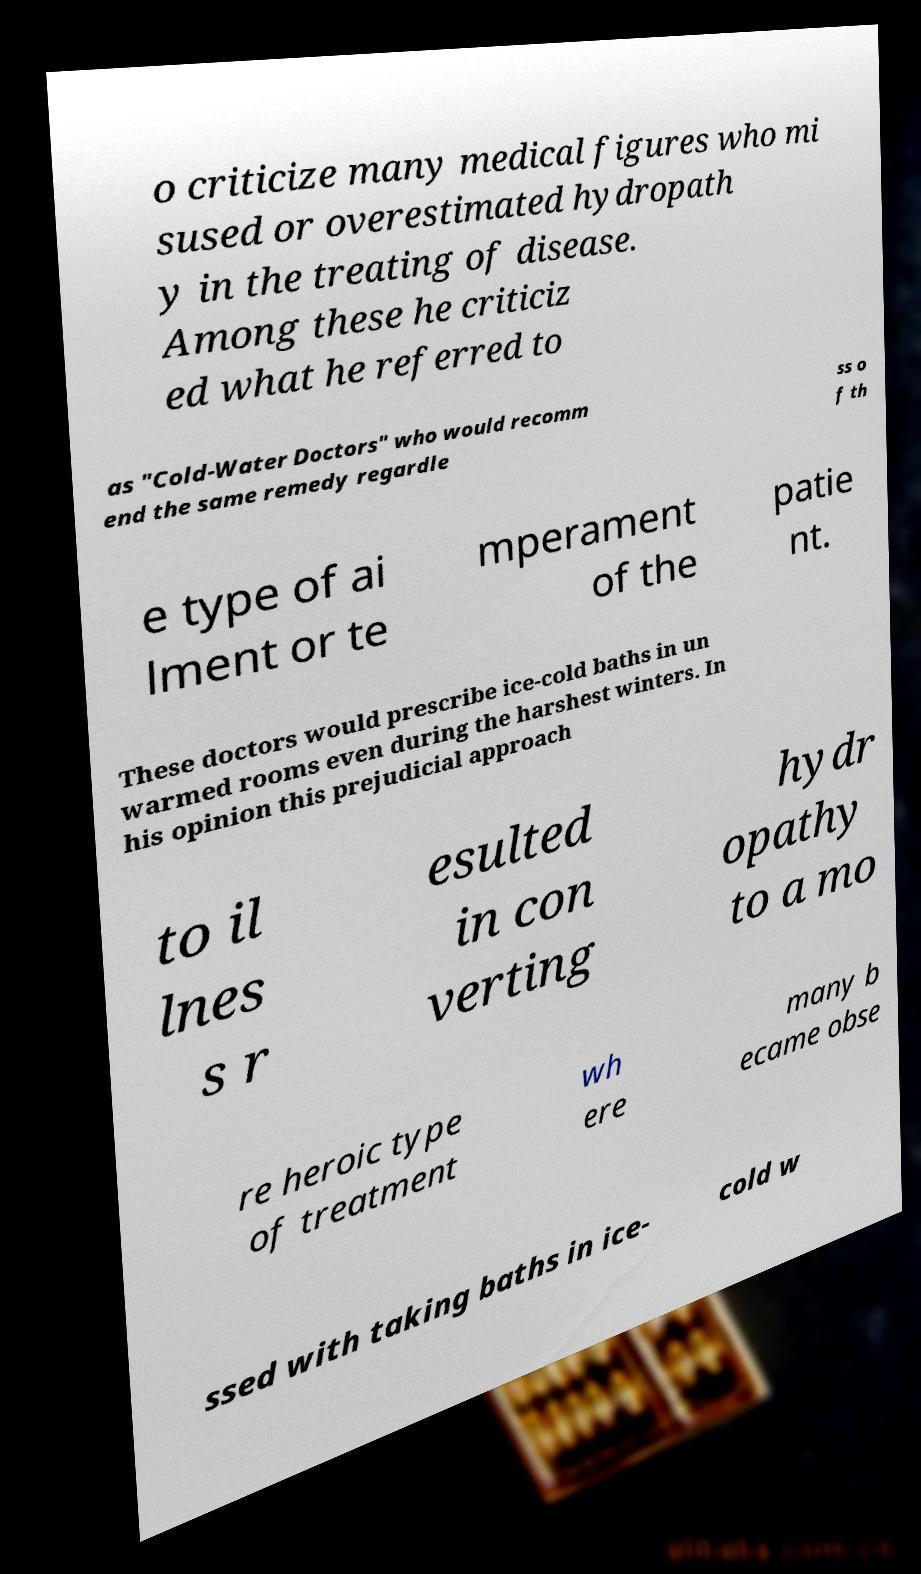Could you assist in decoding the text presented in this image and type it out clearly? o criticize many medical figures who mi sused or overestimated hydropath y in the treating of disease. Among these he criticiz ed what he referred to as "Cold-Water Doctors" who would recomm end the same remedy regardle ss o f th e type of ai lment or te mperament of the patie nt. These doctors would prescribe ice-cold baths in un warmed rooms even during the harshest winters. In his opinion this prejudicial approach to il lnes s r esulted in con verting hydr opathy to a mo re heroic type of treatment wh ere many b ecame obse ssed with taking baths in ice- cold w 